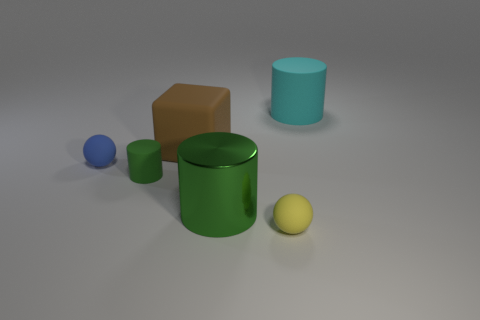How many things are tiny green balls or rubber things that are in front of the big brown rubber block?
Your response must be concise. 3. What number of other objects are the same size as the shiny cylinder?
Keep it short and to the point. 2. What is the material of the other tiny object that is the same shape as the cyan matte thing?
Provide a succinct answer. Rubber. Are there more cylinders that are to the right of the small green object than cyan rubber balls?
Give a very brief answer. Yes. Are there any other things that are the same color as the large matte block?
Keep it short and to the point. No. There is a large brown thing that is made of the same material as the blue thing; what is its shape?
Make the answer very short. Cube. Are the tiny sphere behind the small yellow thing and the tiny green thing made of the same material?
Keep it short and to the point. Yes. What shape is the large metallic thing that is the same color as the tiny rubber cylinder?
Offer a very short reply. Cylinder. Is the color of the matte cylinder that is on the left side of the shiny thing the same as the large object in front of the blue sphere?
Your answer should be very brief. Yes. What number of tiny spheres are both on the left side of the yellow ball and to the right of the brown rubber block?
Provide a short and direct response. 0. 